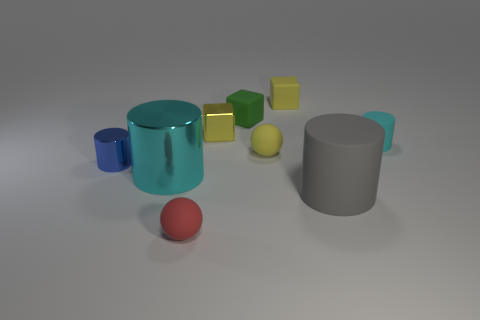There is a matte object behind the tiny green rubber block to the right of the large cyan metallic object; what is its size?
Your answer should be compact. Small. Is there anything else that is made of the same material as the tiny green object?
Offer a terse response. Yes. Are there more tiny blocks than small shiny things?
Your answer should be very brief. Yes. Is the color of the tiny thing that is on the right side of the gray cylinder the same as the sphere that is behind the gray thing?
Offer a terse response. No. There is a tiny rubber block that is on the right side of the tiny yellow matte sphere; are there any tiny green rubber objects behind it?
Your answer should be compact. No. Is the number of small red rubber things on the right side of the tiny red sphere less than the number of small rubber cubes that are behind the green thing?
Offer a very short reply. Yes. Is the small cylinder that is in front of the tiny cyan cylinder made of the same material as the large object that is behind the gray matte object?
Offer a terse response. Yes. What number of small things are either yellow things or rubber balls?
Your answer should be compact. 4. There is a red thing that is made of the same material as the green cube; what is its shape?
Give a very brief answer. Sphere. Are there fewer blue shiny cylinders that are to the right of the tiny green rubber object than small matte blocks?
Keep it short and to the point. Yes. 